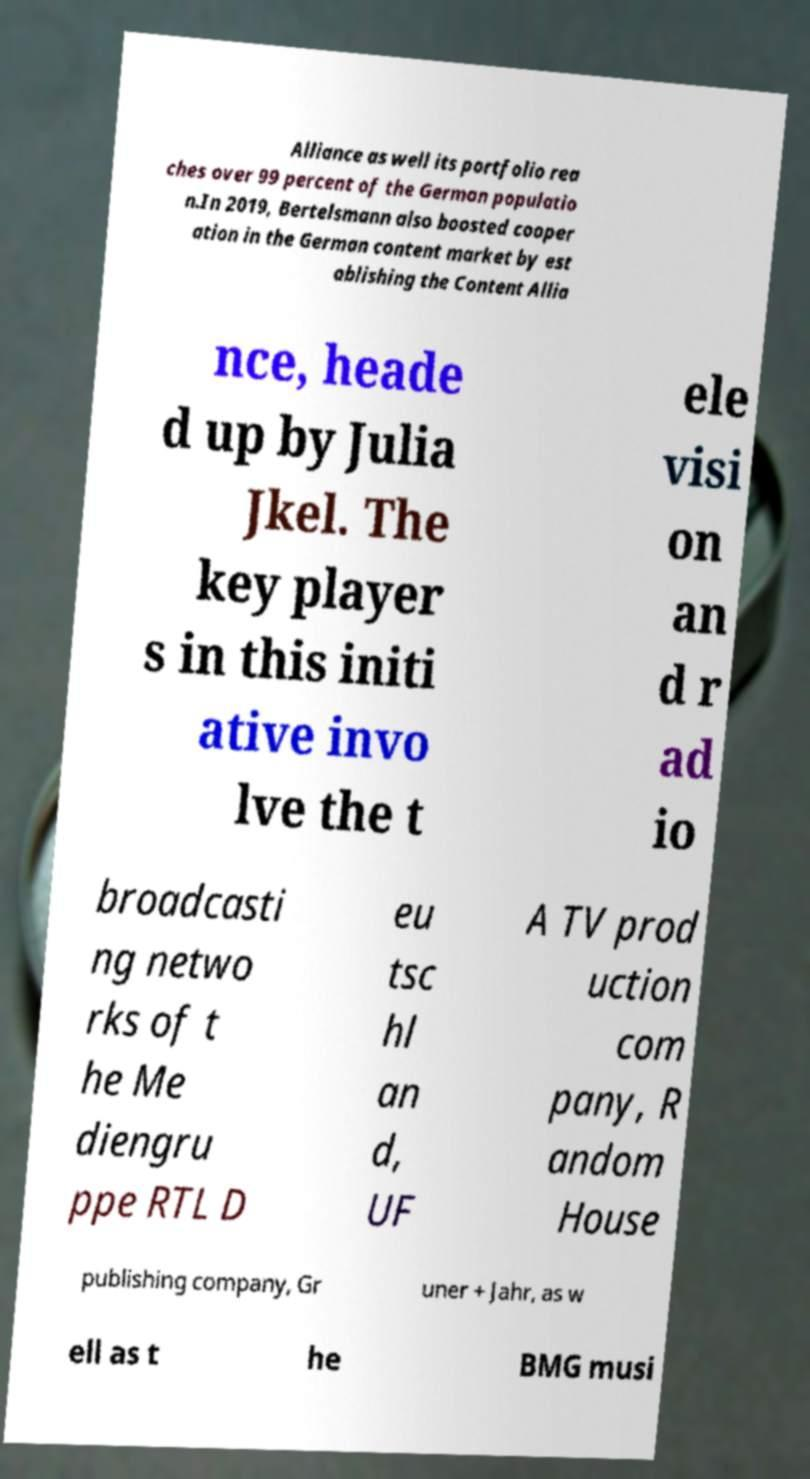What messages or text are displayed in this image? I need them in a readable, typed format. Alliance as well its portfolio rea ches over 99 percent of the German populatio n.In 2019, Bertelsmann also boosted cooper ation in the German content market by est ablishing the Content Allia nce, heade d up by Julia Jkel. The key player s in this initi ative invo lve the t ele visi on an d r ad io broadcasti ng netwo rks of t he Me diengru ppe RTL D eu tsc hl an d, UF A TV prod uction com pany, R andom House publishing company, Gr uner + Jahr, as w ell as t he BMG musi 